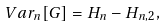<formula> <loc_0><loc_0><loc_500><loc_500>V a r _ { n } [ G ] = H _ { n } - H _ { n , 2 } ,</formula> 